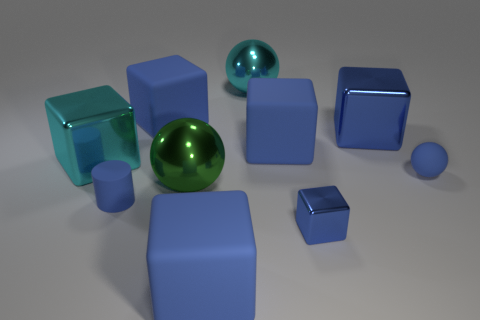What is the material of the large blue thing that is behind the blue metallic block that is behind the cyan object that is left of the big cyan ball?
Your answer should be very brief. Rubber. What is the shape of the large metallic object that is in front of the tiny blue rubber sphere?
Offer a very short reply. Sphere. There is a blue thing that is the same material as the small blue block; what size is it?
Ensure brevity in your answer.  Large. What number of other things have the same shape as the big green metallic thing?
Provide a succinct answer. 2. There is a big matte thing to the right of the cyan ball; is it the same color as the small shiny object?
Provide a succinct answer. Yes. How many blue cylinders are in front of the large shiny sphere that is right of the large blue matte block in front of the tiny blue metallic thing?
Provide a succinct answer. 1. How many tiny blue things are to the left of the blue matte sphere and behind the tiny metallic thing?
Your response must be concise. 1. What shape is the metal object that is the same color as the tiny cube?
Provide a short and direct response. Cube. Do the tiny blue cube and the cylinder have the same material?
Your response must be concise. No. What is the shape of the small blue matte thing on the right side of the tiny blue thing that is left of the big blue cube in front of the blue cylinder?
Your answer should be very brief. Sphere. 